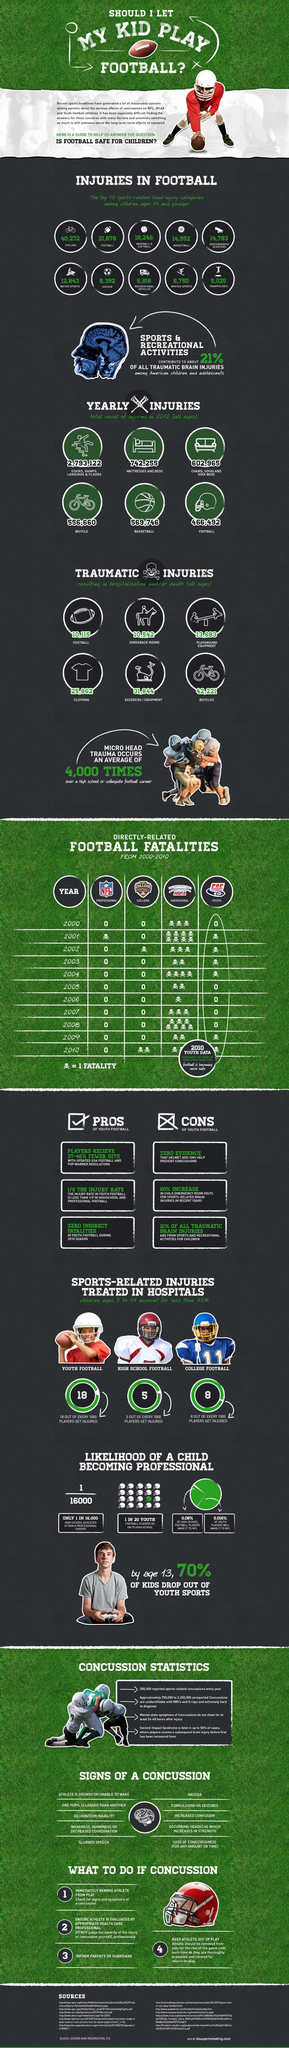Mention a couple of crucial points in this snapshot. The skull symbol represents a single fatality. Approximately 0.5% of high school football players are injured during games or practices. The number of sources listed at the bottom is 11. Out of all high school and youth players, a mere 0.096% go on to play in the National Football League. According to reports, a staggering 63,468 injuries are recorded annually in sports involving balls. 